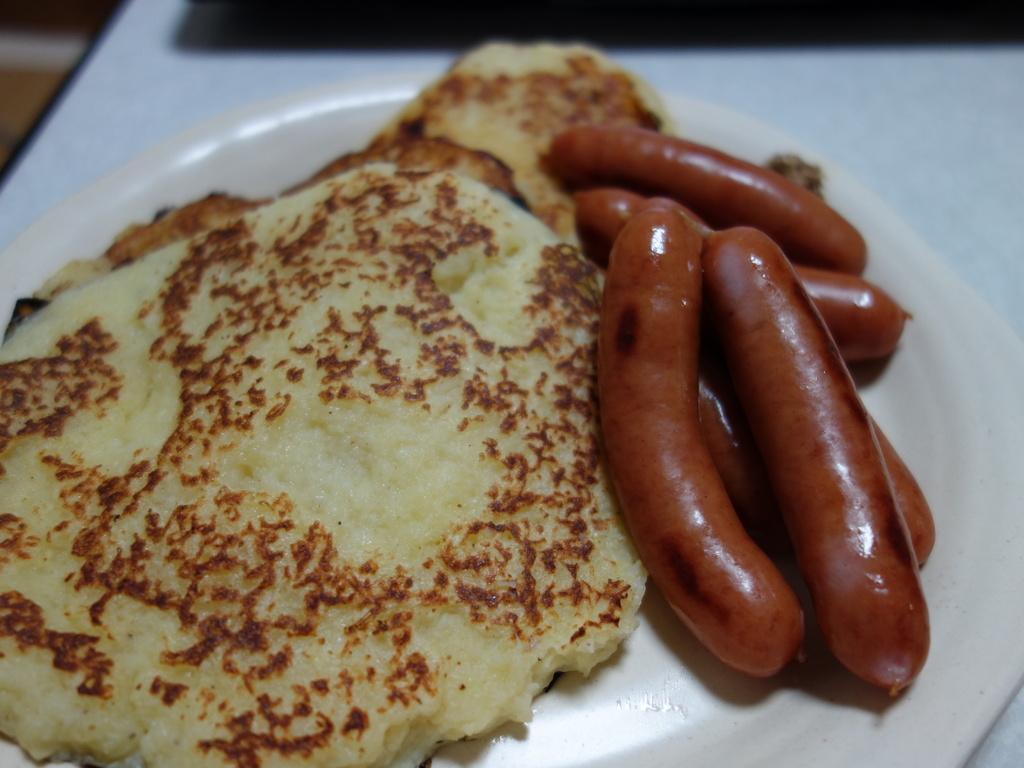Can you describe this image briefly? In this image, we can see a plate on the table contains pancakes and sausages. 